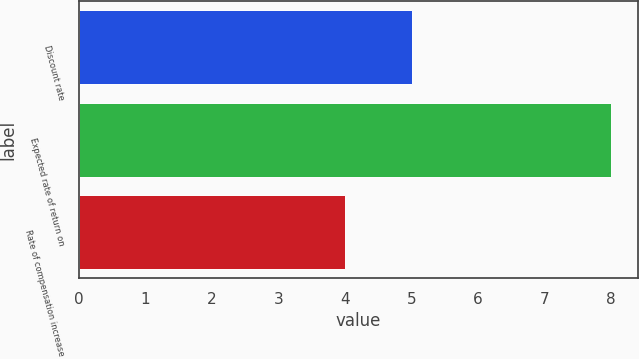<chart> <loc_0><loc_0><loc_500><loc_500><bar_chart><fcel>Discount rate<fcel>Expected rate of return on<fcel>Rate of compensation increase<nl><fcel>5<fcel>8<fcel>4<nl></chart> 